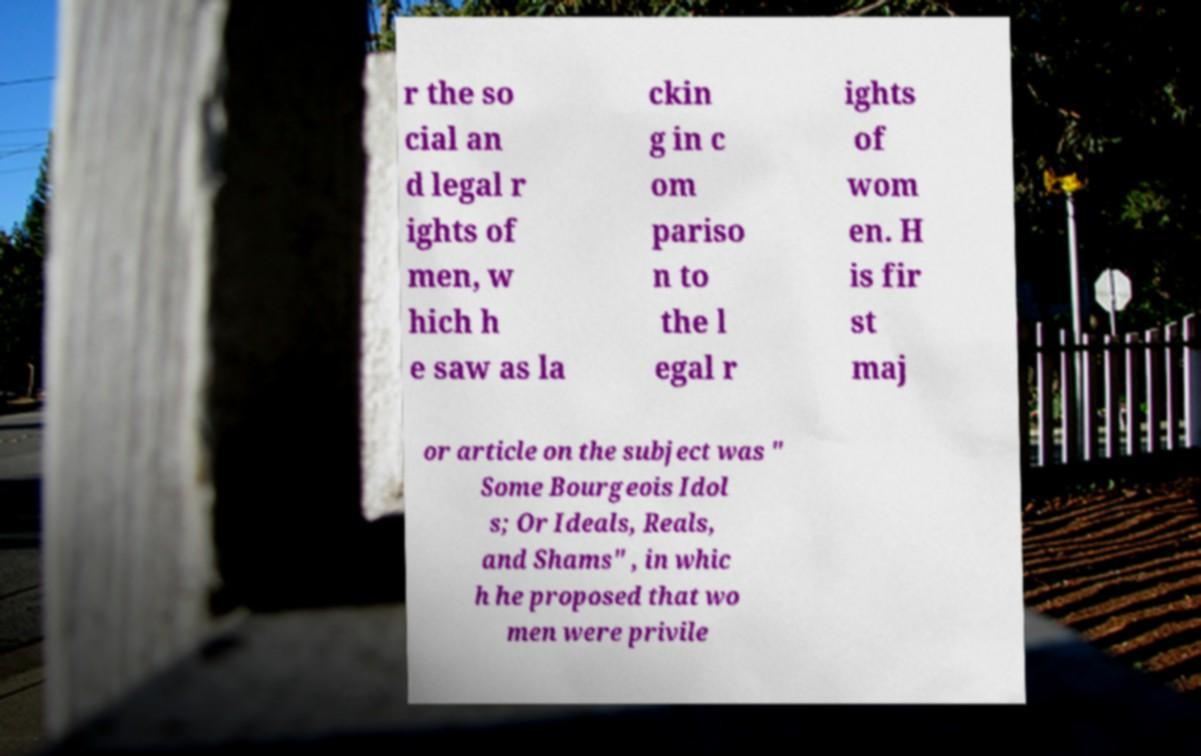Please read and relay the text visible in this image. What does it say? r the so cial an d legal r ights of men, w hich h e saw as la ckin g in c om pariso n to the l egal r ights of wom en. H is fir st maj or article on the subject was " Some Bourgeois Idol s; Or Ideals, Reals, and Shams" , in whic h he proposed that wo men were privile 